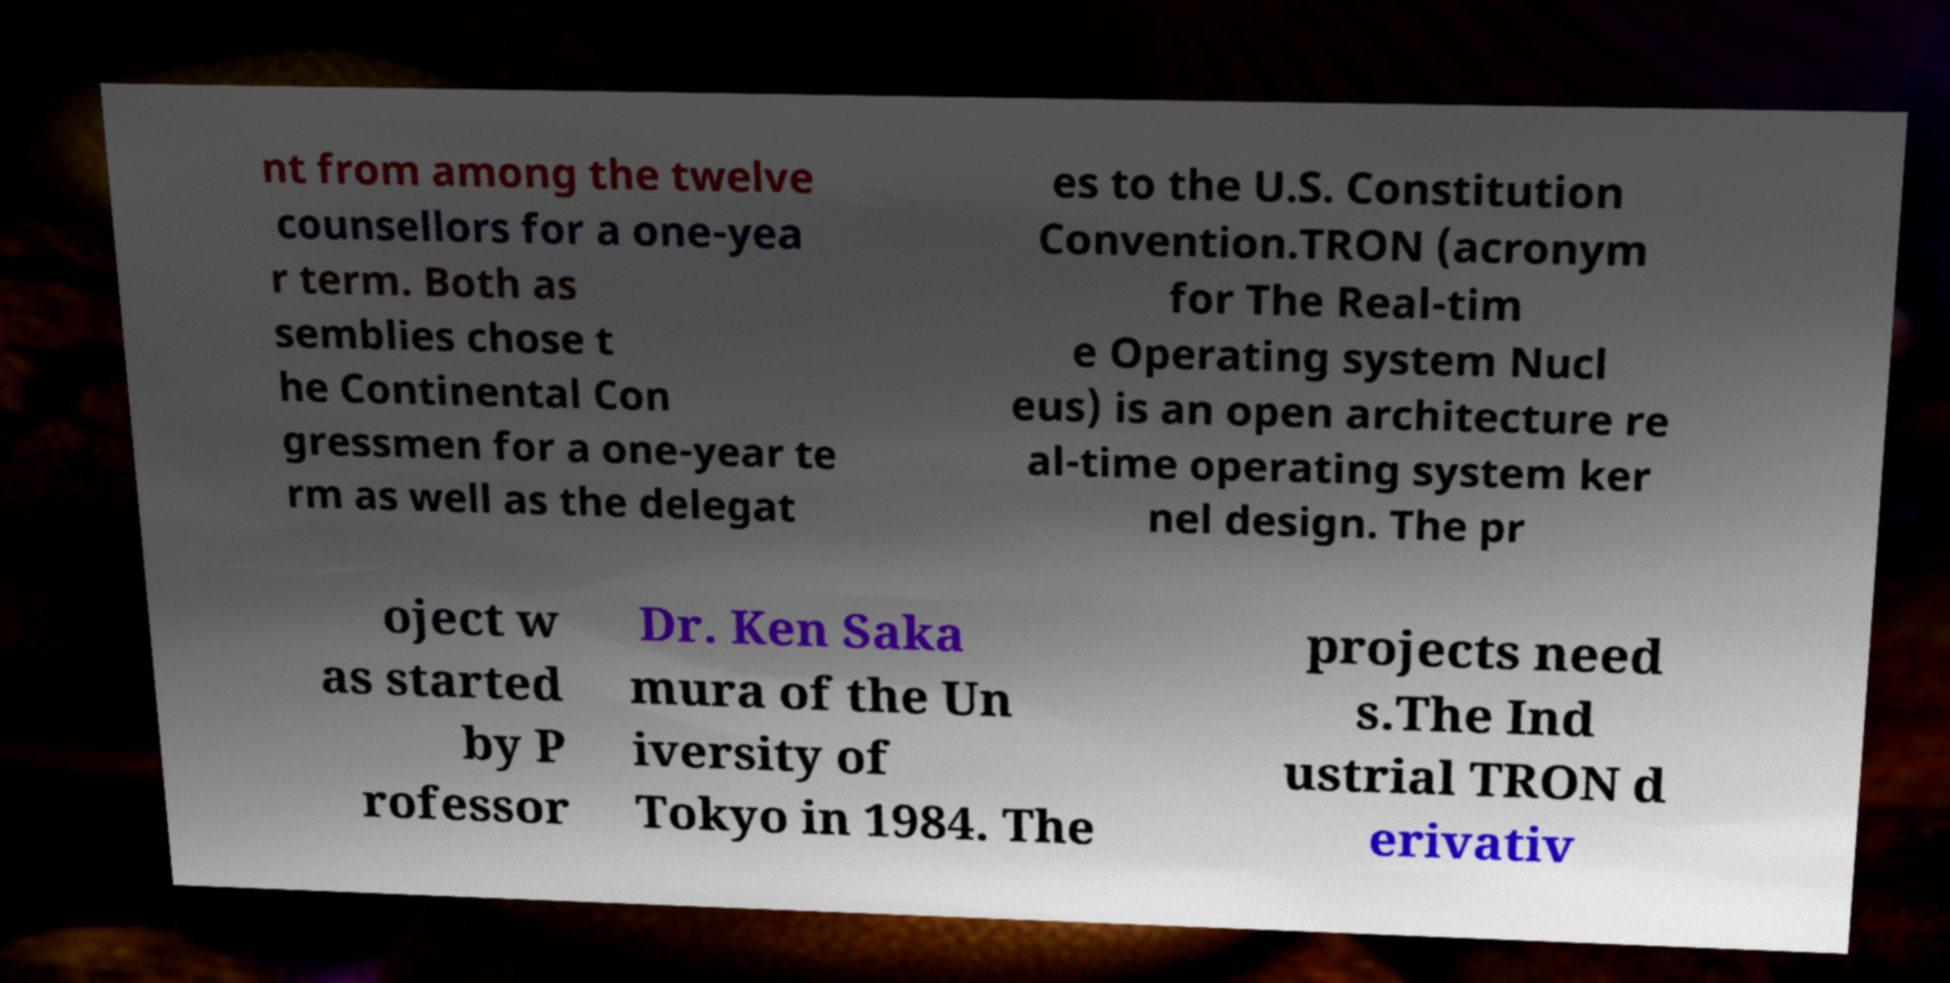Can you accurately transcribe the text from the provided image for me? nt from among the twelve counsellors for a one-yea r term. Both as semblies chose t he Continental Con gressmen for a one-year te rm as well as the delegat es to the U.S. Constitution Convention.TRON (acronym for The Real-tim e Operating system Nucl eus) is an open architecture re al-time operating system ker nel design. The pr oject w as started by P rofessor Dr. Ken Saka mura of the Un iversity of Tokyo in 1984. The projects need s.The Ind ustrial TRON d erivativ 